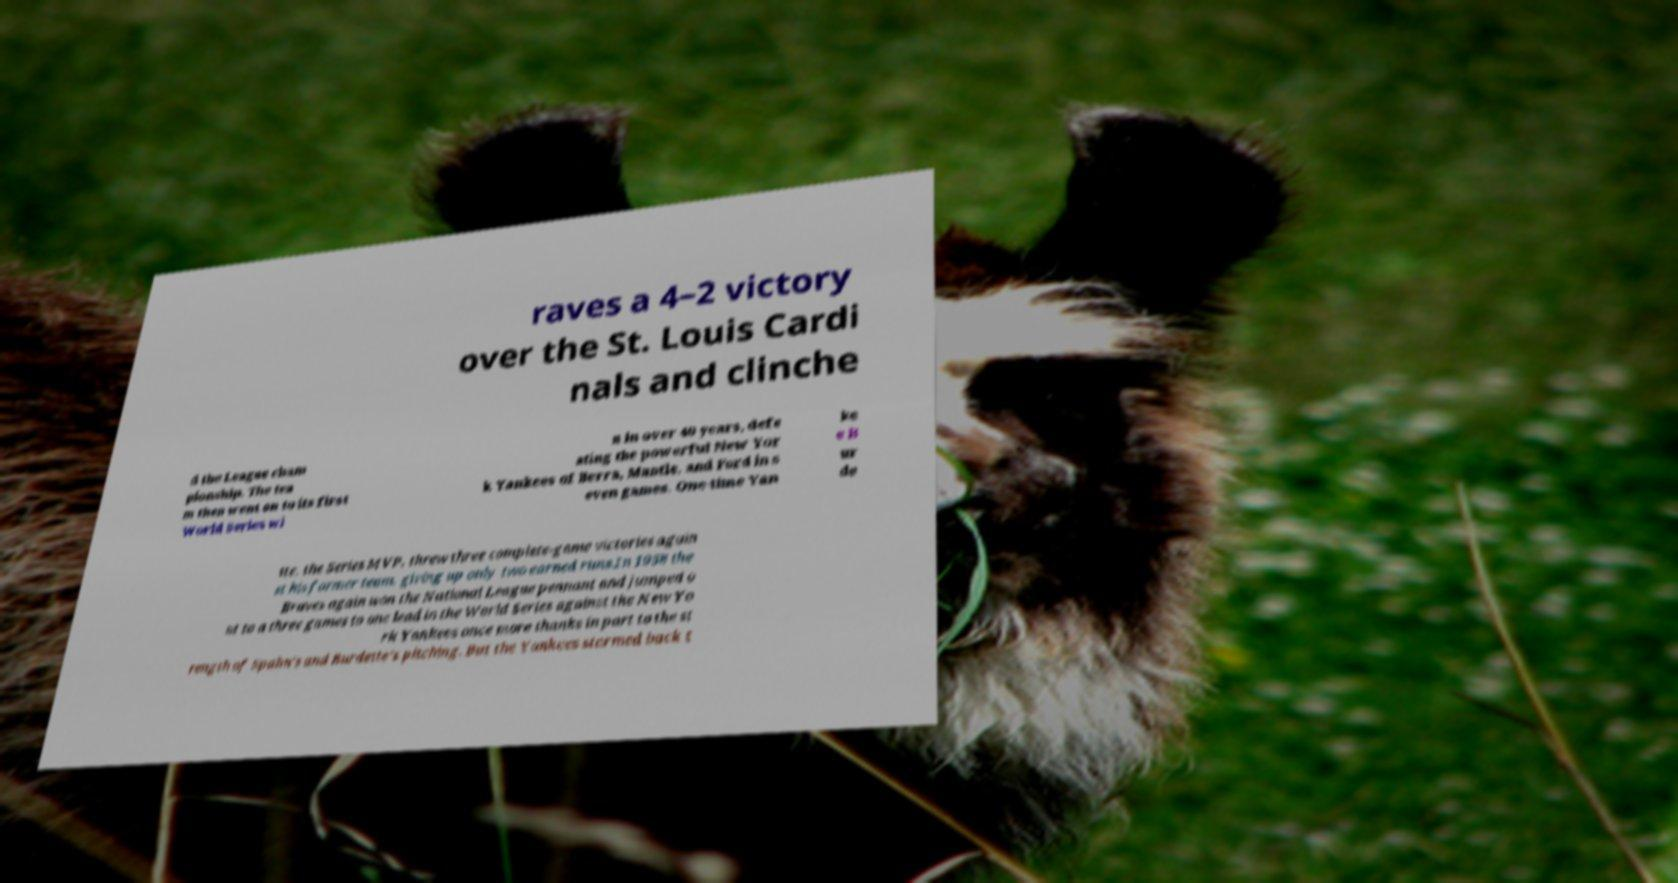For documentation purposes, I need the text within this image transcribed. Could you provide that? raves a 4–2 victory over the St. Louis Cardi nals and clinche d the League cham pionship. The tea m then went on to its first World Series wi n in over 40 years, defe ating the powerful New Yor k Yankees of Berra, Mantle, and Ford in s even games. One-time Yan ke e B ur de tte, the Series MVP, threw three complete-game victories again st his former team, giving up only two earned runs.In 1958 the Braves again won the National League pennant and jumped o ut to a three games to one lead in the World Series against the New Yo rk Yankees once more thanks in part to the st rength of Spahn's and Burdette's pitching. But the Yankees stormed back t 